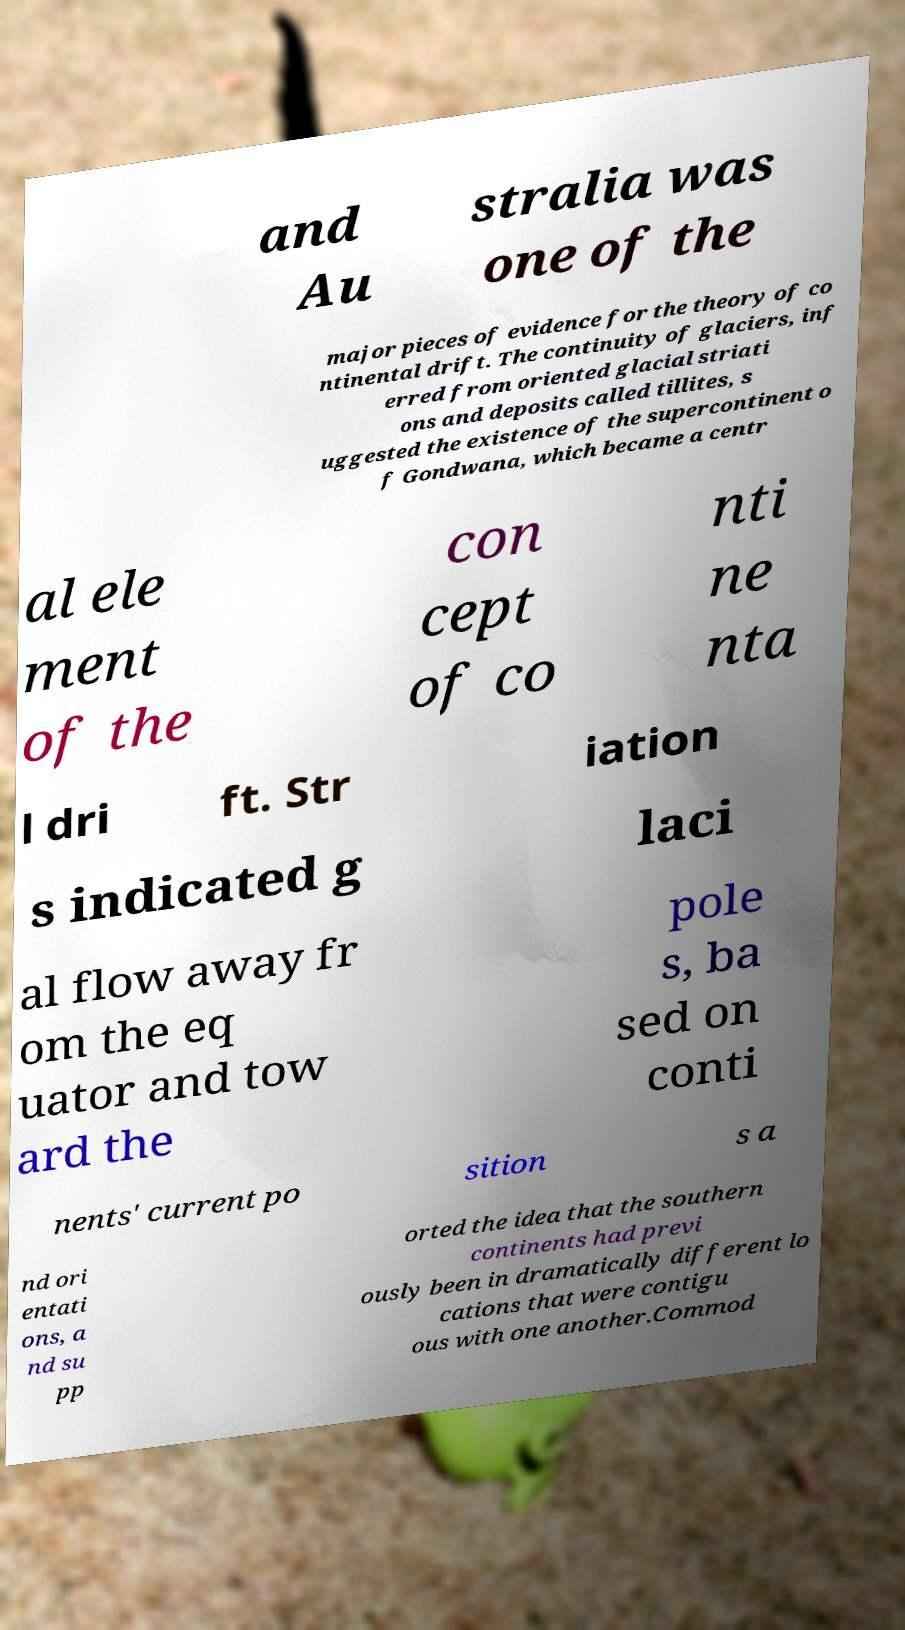Please identify and transcribe the text found in this image. and Au stralia was one of the major pieces of evidence for the theory of co ntinental drift. The continuity of glaciers, inf erred from oriented glacial striati ons and deposits called tillites, s uggested the existence of the supercontinent o f Gondwana, which became a centr al ele ment of the con cept of co nti ne nta l dri ft. Str iation s indicated g laci al flow away fr om the eq uator and tow ard the pole s, ba sed on conti nents' current po sition s a nd ori entati ons, a nd su pp orted the idea that the southern continents had previ ously been in dramatically different lo cations that were contigu ous with one another.Commod 